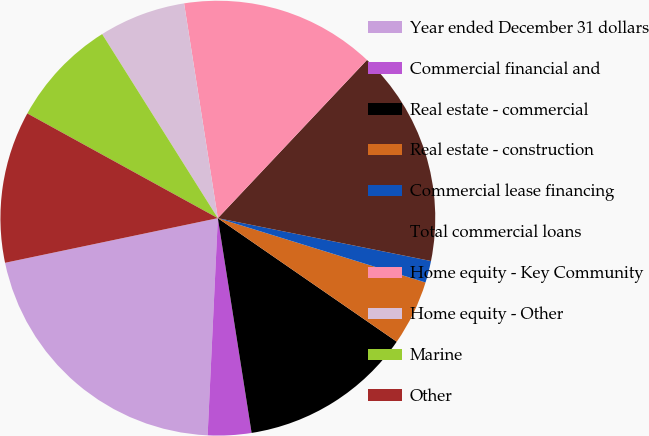Convert chart. <chart><loc_0><loc_0><loc_500><loc_500><pie_chart><fcel>Year ended December 31 dollars<fcel>Commercial financial and<fcel>Real estate - commercial<fcel>Real estate - construction<fcel>Commercial lease financing<fcel>Total commercial loans<fcel>Home equity - Key Community<fcel>Home equity - Other<fcel>Marine<fcel>Other<nl><fcel>20.96%<fcel>3.23%<fcel>12.9%<fcel>4.84%<fcel>1.62%<fcel>16.13%<fcel>14.51%<fcel>6.45%<fcel>8.07%<fcel>11.29%<nl></chart> 